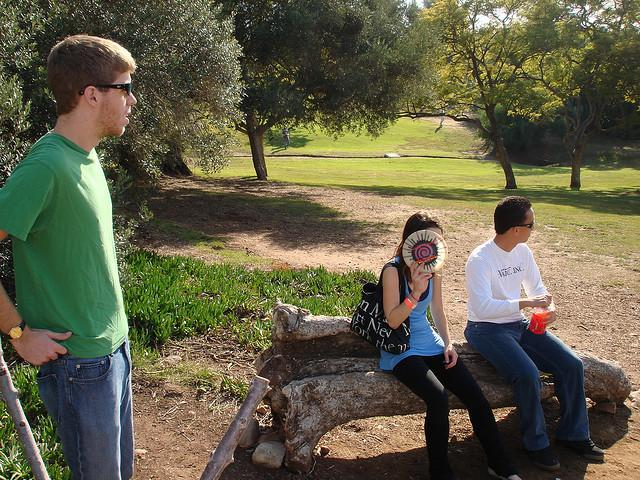Why is she holding up the item? Please explain your reasoning. camera shy. She doesn't want her face shown whereever the person plans on uploading the picture. 